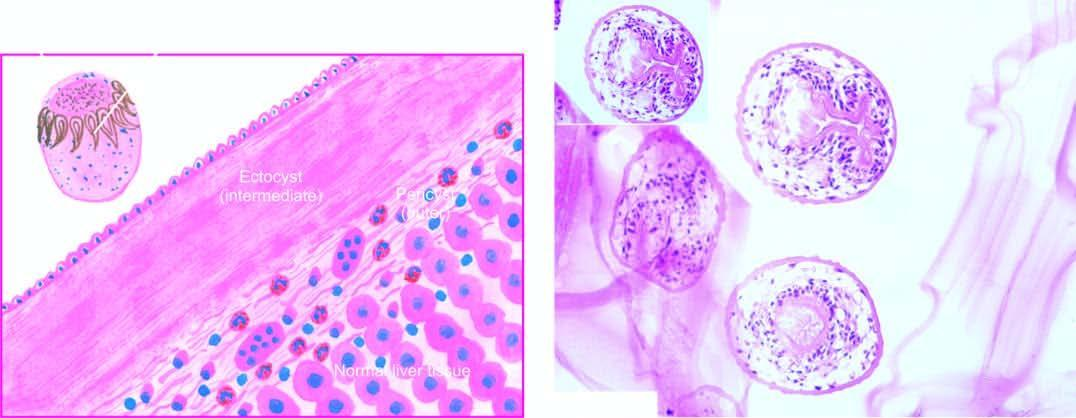what does inbox in the right photomicrograph show?
Answer the question using a single word or phrase. A scolex with a row of hooklets 